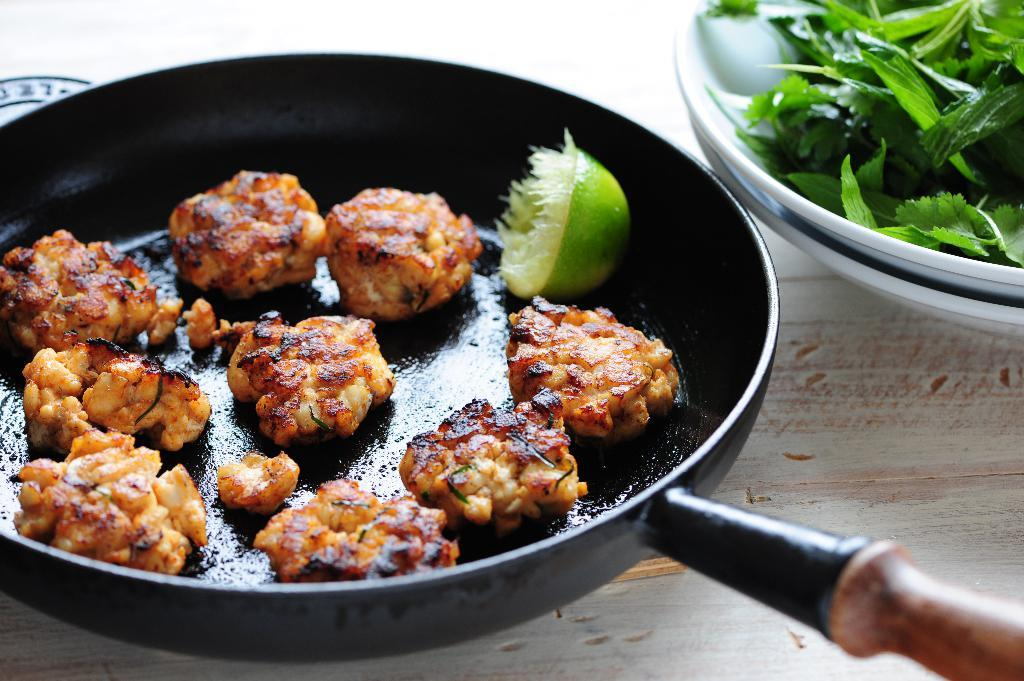What is in the pan that is visible in the image? There is a pan with crispy food in the image. What other items can be seen in the image? There is a lemon and a bowl with nettle leaves in the image. Where are the pan and the bowl located in the image? Both the pan and the bowl are on a table in the image. What type of balloon is floating above the pan in the image? There is no balloon present in the image. How does the sponge help in the preparation of the crispy food in the image? There is no sponge mentioned or visible in the image. 